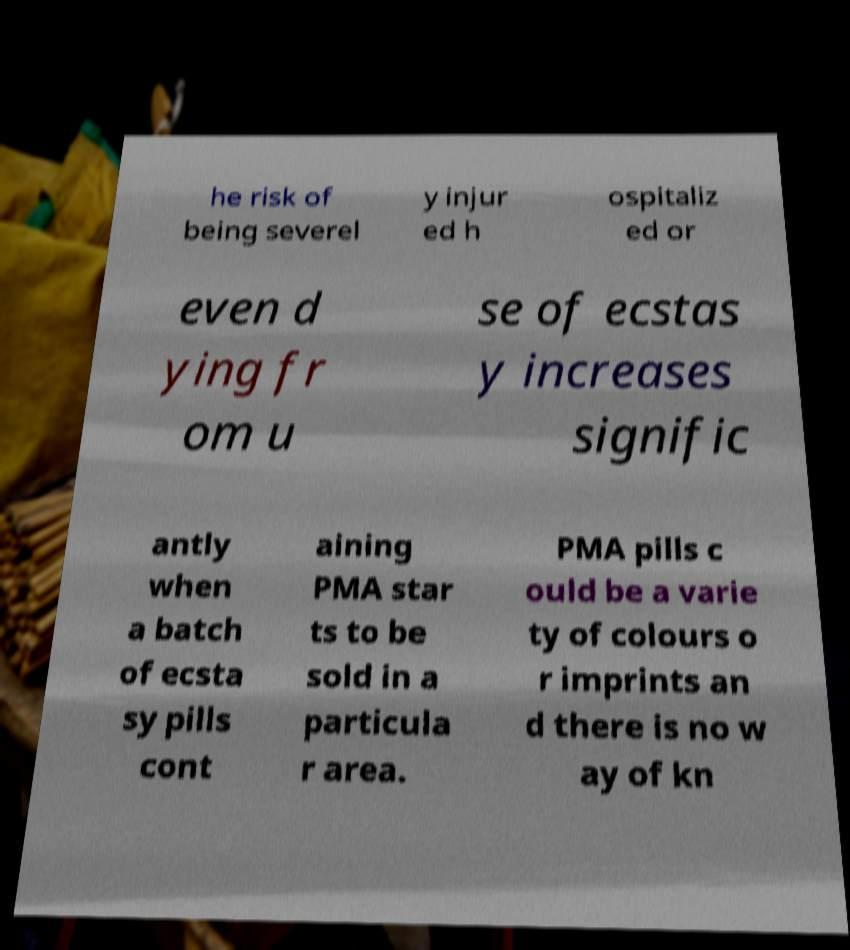Could you extract and type out the text from this image? he risk of being severel y injur ed h ospitaliz ed or even d ying fr om u se of ecstas y increases signific antly when a batch of ecsta sy pills cont aining PMA star ts to be sold in a particula r area. PMA pills c ould be a varie ty of colours o r imprints an d there is no w ay of kn 